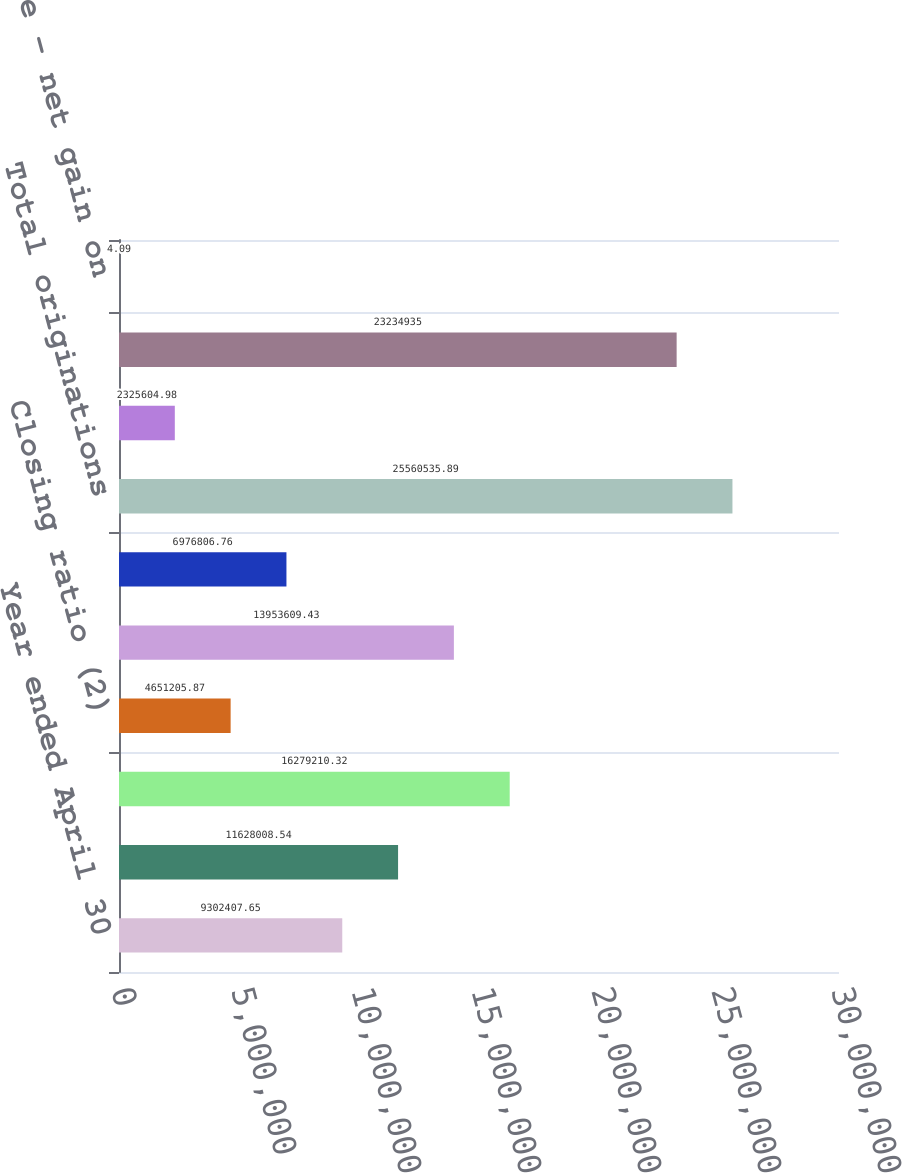Convert chart to OTSL. <chart><loc_0><loc_0><loc_500><loc_500><bar_chart><fcel>Year ended April 30<fcel>Number of sales associates (1)<fcel>Total number of applications<fcel>Closing ratio (2)<fcel>Total number of originations<fcel>Average loan size<fcel>Total originations<fcel>Non-prime/prime origination<fcel>Loan sales<fcel>Execution price - net gain on<nl><fcel>9.30241e+06<fcel>1.1628e+07<fcel>1.62792e+07<fcel>4.65121e+06<fcel>1.39536e+07<fcel>6.97681e+06<fcel>2.55605e+07<fcel>2.3256e+06<fcel>2.32349e+07<fcel>4.09<nl></chart> 